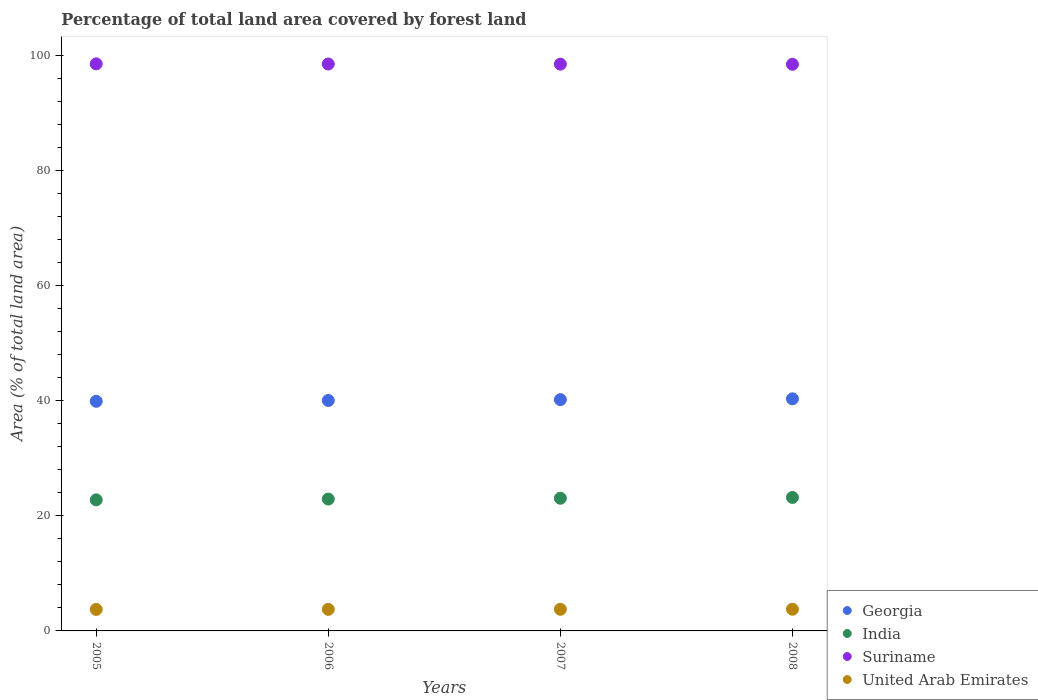How many different coloured dotlines are there?
Your answer should be very brief. 4. What is the percentage of forest land in Suriname in 2005?
Keep it short and to the point. 98.53. Across all years, what is the maximum percentage of forest land in Georgia?
Give a very brief answer. 40.33. Across all years, what is the minimum percentage of forest land in United Arab Emirates?
Your answer should be very brief. 3.73. In which year was the percentage of forest land in United Arab Emirates maximum?
Ensure brevity in your answer.  2008. In which year was the percentage of forest land in Suriname minimum?
Your response must be concise. 2008. What is the total percentage of forest land in Georgia in the graph?
Offer a very short reply. 160.45. What is the difference between the percentage of forest land in India in 2005 and that in 2006?
Offer a very short reply. -0.14. What is the difference between the percentage of forest land in United Arab Emirates in 2005 and the percentage of forest land in Suriname in 2007?
Offer a terse response. -94.75. What is the average percentage of forest land in Suriname per year?
Offer a terse response. 98.49. In the year 2008, what is the difference between the percentage of forest land in Georgia and percentage of forest land in Suriname?
Offer a terse response. -58.13. In how many years, is the percentage of forest land in Suriname greater than 64 %?
Keep it short and to the point. 4. What is the ratio of the percentage of forest land in India in 2005 to that in 2008?
Give a very brief answer. 0.98. What is the difference between the highest and the second highest percentage of forest land in Georgia?
Keep it short and to the point. 0.14. What is the difference between the highest and the lowest percentage of forest land in United Arab Emirates?
Your answer should be compact. 0.04. Is it the case that in every year, the sum of the percentage of forest land in Georgia and percentage of forest land in Suriname  is greater than the sum of percentage of forest land in United Arab Emirates and percentage of forest land in India?
Provide a short and direct response. No. Is it the case that in every year, the sum of the percentage of forest land in India and percentage of forest land in Suriname  is greater than the percentage of forest land in United Arab Emirates?
Make the answer very short. Yes. Does the percentage of forest land in Suriname monotonically increase over the years?
Offer a very short reply. No. Is the percentage of forest land in India strictly greater than the percentage of forest land in United Arab Emirates over the years?
Offer a very short reply. Yes. Is the percentage of forest land in Suriname strictly less than the percentage of forest land in India over the years?
Your response must be concise. No. What is the difference between two consecutive major ticks on the Y-axis?
Provide a short and direct response. 20. Does the graph contain grids?
Ensure brevity in your answer.  No. Where does the legend appear in the graph?
Ensure brevity in your answer.  Bottom right. How many legend labels are there?
Give a very brief answer. 4. How are the legend labels stacked?
Your answer should be compact. Vertical. What is the title of the graph?
Make the answer very short. Percentage of total land area covered by forest land. What is the label or title of the X-axis?
Provide a succinct answer. Years. What is the label or title of the Y-axis?
Your response must be concise. Area (% of total land area). What is the Area (% of total land area) of Georgia in 2005?
Your answer should be very brief. 39.9. What is the Area (% of total land area) in India in 2005?
Give a very brief answer. 22.77. What is the Area (% of total land area) of Suriname in 2005?
Your answer should be compact. 98.53. What is the Area (% of total land area) of United Arab Emirates in 2005?
Offer a terse response. 3.73. What is the Area (% of total land area) of Georgia in 2006?
Offer a terse response. 40.04. What is the Area (% of total land area) of India in 2006?
Make the answer very short. 22.91. What is the Area (% of total land area) of Suriname in 2006?
Offer a terse response. 98.51. What is the Area (% of total land area) of United Arab Emirates in 2006?
Your answer should be very brief. 3.74. What is the Area (% of total land area) in Georgia in 2007?
Your answer should be very brief. 40.19. What is the Area (% of total land area) in India in 2007?
Your response must be concise. 23.05. What is the Area (% of total land area) of Suriname in 2007?
Provide a succinct answer. 98.48. What is the Area (% of total land area) in United Arab Emirates in 2007?
Keep it short and to the point. 3.76. What is the Area (% of total land area) of Georgia in 2008?
Offer a very short reply. 40.33. What is the Area (% of total land area) of India in 2008?
Offer a terse response. 23.19. What is the Area (% of total land area) of Suriname in 2008?
Provide a short and direct response. 98.46. What is the Area (% of total land area) in United Arab Emirates in 2008?
Give a very brief answer. 3.77. Across all years, what is the maximum Area (% of total land area) of Georgia?
Offer a terse response. 40.33. Across all years, what is the maximum Area (% of total land area) in India?
Make the answer very short. 23.19. Across all years, what is the maximum Area (% of total land area) of Suriname?
Provide a succinct answer. 98.53. Across all years, what is the maximum Area (% of total land area) of United Arab Emirates?
Make the answer very short. 3.77. Across all years, what is the minimum Area (% of total land area) of Georgia?
Your response must be concise. 39.9. Across all years, what is the minimum Area (% of total land area) in India?
Make the answer very short. 22.77. Across all years, what is the minimum Area (% of total land area) of Suriname?
Your answer should be compact. 98.46. Across all years, what is the minimum Area (% of total land area) of United Arab Emirates?
Your answer should be very brief. 3.73. What is the total Area (% of total land area) of Georgia in the graph?
Offer a terse response. 160.45. What is the total Area (% of total land area) in India in the graph?
Provide a succinct answer. 91.93. What is the total Area (% of total land area) in Suriname in the graph?
Make the answer very short. 393.97. What is the total Area (% of total land area) in United Arab Emirates in the graph?
Provide a succinct answer. 15. What is the difference between the Area (% of total land area) in Georgia in 2005 and that in 2006?
Offer a very short reply. -0.14. What is the difference between the Area (% of total land area) in India in 2005 and that in 2006?
Your answer should be very brief. -0.14. What is the difference between the Area (% of total land area) in Suriname in 2005 and that in 2006?
Offer a terse response. 0.03. What is the difference between the Area (% of total land area) of United Arab Emirates in 2005 and that in 2006?
Offer a very short reply. -0.01. What is the difference between the Area (% of total land area) of Georgia in 2005 and that in 2007?
Offer a very short reply. -0.29. What is the difference between the Area (% of total land area) in India in 2005 and that in 2007?
Provide a short and direct response. -0.28. What is the difference between the Area (% of total land area) in Suriname in 2005 and that in 2007?
Ensure brevity in your answer.  0.05. What is the difference between the Area (% of total land area) in United Arab Emirates in 2005 and that in 2007?
Your answer should be compact. -0.03. What is the difference between the Area (% of total land area) of Georgia in 2005 and that in 2008?
Give a very brief answer. -0.43. What is the difference between the Area (% of total land area) of India in 2005 and that in 2008?
Your answer should be compact. -0.42. What is the difference between the Area (% of total land area) in Suriname in 2005 and that in 2008?
Provide a succinct answer. 0.08. What is the difference between the Area (% of total land area) in United Arab Emirates in 2005 and that in 2008?
Keep it short and to the point. -0.04. What is the difference between the Area (% of total land area) of Georgia in 2006 and that in 2007?
Your answer should be very brief. -0.14. What is the difference between the Area (% of total land area) in India in 2006 and that in 2007?
Provide a short and direct response. -0.14. What is the difference between the Area (% of total land area) of Suriname in 2006 and that in 2007?
Your answer should be very brief. 0.03. What is the difference between the Area (% of total land area) of United Arab Emirates in 2006 and that in 2007?
Keep it short and to the point. -0.01. What is the difference between the Area (% of total land area) in Georgia in 2006 and that in 2008?
Your response must be concise. -0.29. What is the difference between the Area (% of total land area) in India in 2006 and that in 2008?
Make the answer very short. -0.28. What is the difference between the Area (% of total land area) of Suriname in 2006 and that in 2008?
Provide a short and direct response. 0.05. What is the difference between the Area (% of total land area) in United Arab Emirates in 2006 and that in 2008?
Keep it short and to the point. -0.03. What is the difference between the Area (% of total land area) of Georgia in 2007 and that in 2008?
Keep it short and to the point. -0.14. What is the difference between the Area (% of total land area) of India in 2007 and that in 2008?
Provide a short and direct response. -0.14. What is the difference between the Area (% of total land area) of Suriname in 2007 and that in 2008?
Keep it short and to the point. 0.03. What is the difference between the Area (% of total land area) of United Arab Emirates in 2007 and that in 2008?
Offer a very short reply. -0.01. What is the difference between the Area (% of total land area) in Georgia in 2005 and the Area (% of total land area) in India in 2006?
Offer a very short reply. 16.98. What is the difference between the Area (% of total land area) of Georgia in 2005 and the Area (% of total land area) of Suriname in 2006?
Keep it short and to the point. -58.61. What is the difference between the Area (% of total land area) in Georgia in 2005 and the Area (% of total land area) in United Arab Emirates in 2006?
Give a very brief answer. 36.15. What is the difference between the Area (% of total land area) of India in 2005 and the Area (% of total land area) of Suriname in 2006?
Make the answer very short. -75.73. What is the difference between the Area (% of total land area) in India in 2005 and the Area (% of total land area) in United Arab Emirates in 2006?
Your answer should be very brief. 19.03. What is the difference between the Area (% of total land area) of Suriname in 2005 and the Area (% of total land area) of United Arab Emirates in 2006?
Keep it short and to the point. 94.79. What is the difference between the Area (% of total land area) in Georgia in 2005 and the Area (% of total land area) in India in 2007?
Offer a terse response. 16.84. What is the difference between the Area (% of total land area) in Georgia in 2005 and the Area (% of total land area) in Suriname in 2007?
Ensure brevity in your answer.  -58.58. What is the difference between the Area (% of total land area) of Georgia in 2005 and the Area (% of total land area) of United Arab Emirates in 2007?
Offer a very short reply. 36.14. What is the difference between the Area (% of total land area) in India in 2005 and the Area (% of total land area) in Suriname in 2007?
Make the answer very short. -75.71. What is the difference between the Area (% of total land area) of India in 2005 and the Area (% of total land area) of United Arab Emirates in 2007?
Your response must be concise. 19.02. What is the difference between the Area (% of total land area) in Suriname in 2005 and the Area (% of total land area) in United Arab Emirates in 2007?
Offer a terse response. 94.77. What is the difference between the Area (% of total land area) in Georgia in 2005 and the Area (% of total land area) in India in 2008?
Offer a terse response. 16.7. What is the difference between the Area (% of total land area) of Georgia in 2005 and the Area (% of total land area) of Suriname in 2008?
Your answer should be very brief. -58.56. What is the difference between the Area (% of total land area) in Georgia in 2005 and the Area (% of total land area) in United Arab Emirates in 2008?
Provide a succinct answer. 36.13. What is the difference between the Area (% of total land area) of India in 2005 and the Area (% of total land area) of Suriname in 2008?
Your answer should be compact. -75.68. What is the difference between the Area (% of total land area) of India in 2005 and the Area (% of total land area) of United Arab Emirates in 2008?
Keep it short and to the point. 19. What is the difference between the Area (% of total land area) in Suriname in 2005 and the Area (% of total land area) in United Arab Emirates in 2008?
Provide a succinct answer. 94.76. What is the difference between the Area (% of total land area) of Georgia in 2006 and the Area (% of total land area) of India in 2007?
Offer a terse response. 16.99. What is the difference between the Area (% of total land area) in Georgia in 2006 and the Area (% of total land area) in Suriname in 2007?
Keep it short and to the point. -58.44. What is the difference between the Area (% of total land area) of Georgia in 2006 and the Area (% of total land area) of United Arab Emirates in 2007?
Offer a terse response. 36.28. What is the difference between the Area (% of total land area) of India in 2006 and the Area (% of total land area) of Suriname in 2007?
Your response must be concise. -75.57. What is the difference between the Area (% of total land area) of India in 2006 and the Area (% of total land area) of United Arab Emirates in 2007?
Your response must be concise. 19.16. What is the difference between the Area (% of total land area) in Suriname in 2006 and the Area (% of total land area) in United Arab Emirates in 2007?
Ensure brevity in your answer.  94.75. What is the difference between the Area (% of total land area) in Georgia in 2006 and the Area (% of total land area) in India in 2008?
Make the answer very short. 16.85. What is the difference between the Area (% of total land area) in Georgia in 2006 and the Area (% of total land area) in Suriname in 2008?
Provide a short and direct response. -58.41. What is the difference between the Area (% of total land area) of Georgia in 2006 and the Area (% of total land area) of United Arab Emirates in 2008?
Your response must be concise. 36.27. What is the difference between the Area (% of total land area) of India in 2006 and the Area (% of total land area) of Suriname in 2008?
Your response must be concise. -75.54. What is the difference between the Area (% of total land area) of India in 2006 and the Area (% of total land area) of United Arab Emirates in 2008?
Ensure brevity in your answer.  19.14. What is the difference between the Area (% of total land area) in Suriname in 2006 and the Area (% of total land area) in United Arab Emirates in 2008?
Offer a very short reply. 94.74. What is the difference between the Area (% of total land area) of Georgia in 2007 and the Area (% of total land area) of India in 2008?
Your answer should be compact. 16.99. What is the difference between the Area (% of total land area) of Georgia in 2007 and the Area (% of total land area) of Suriname in 2008?
Your answer should be very brief. -58.27. What is the difference between the Area (% of total land area) of Georgia in 2007 and the Area (% of total land area) of United Arab Emirates in 2008?
Offer a very short reply. 36.41. What is the difference between the Area (% of total land area) of India in 2007 and the Area (% of total land area) of Suriname in 2008?
Offer a terse response. -75.4. What is the difference between the Area (% of total land area) of India in 2007 and the Area (% of total land area) of United Arab Emirates in 2008?
Keep it short and to the point. 19.28. What is the difference between the Area (% of total land area) of Suriname in 2007 and the Area (% of total land area) of United Arab Emirates in 2008?
Offer a terse response. 94.71. What is the average Area (% of total land area) in Georgia per year?
Give a very brief answer. 40.11. What is the average Area (% of total land area) of India per year?
Ensure brevity in your answer.  22.98. What is the average Area (% of total land area) in Suriname per year?
Your answer should be very brief. 98.49. What is the average Area (% of total land area) in United Arab Emirates per year?
Offer a very short reply. 3.75. In the year 2005, what is the difference between the Area (% of total land area) in Georgia and Area (% of total land area) in India?
Provide a succinct answer. 17.12. In the year 2005, what is the difference between the Area (% of total land area) of Georgia and Area (% of total land area) of Suriname?
Keep it short and to the point. -58.63. In the year 2005, what is the difference between the Area (% of total land area) in Georgia and Area (% of total land area) in United Arab Emirates?
Your answer should be compact. 36.17. In the year 2005, what is the difference between the Area (% of total land area) of India and Area (% of total land area) of Suriname?
Your answer should be very brief. -75.76. In the year 2005, what is the difference between the Area (% of total land area) in India and Area (% of total land area) in United Arab Emirates?
Give a very brief answer. 19.04. In the year 2005, what is the difference between the Area (% of total land area) of Suriname and Area (% of total land area) of United Arab Emirates?
Your response must be concise. 94.8. In the year 2006, what is the difference between the Area (% of total land area) of Georgia and Area (% of total land area) of India?
Your answer should be very brief. 17.13. In the year 2006, what is the difference between the Area (% of total land area) in Georgia and Area (% of total land area) in Suriname?
Make the answer very short. -58.47. In the year 2006, what is the difference between the Area (% of total land area) of Georgia and Area (% of total land area) of United Arab Emirates?
Provide a short and direct response. 36.3. In the year 2006, what is the difference between the Area (% of total land area) in India and Area (% of total land area) in Suriname?
Your answer should be compact. -75.59. In the year 2006, what is the difference between the Area (% of total land area) in India and Area (% of total land area) in United Arab Emirates?
Your answer should be compact. 19.17. In the year 2006, what is the difference between the Area (% of total land area) in Suriname and Area (% of total land area) in United Arab Emirates?
Give a very brief answer. 94.76. In the year 2007, what is the difference between the Area (% of total land area) of Georgia and Area (% of total land area) of India?
Your answer should be very brief. 17.13. In the year 2007, what is the difference between the Area (% of total land area) in Georgia and Area (% of total land area) in Suriname?
Your answer should be compact. -58.3. In the year 2007, what is the difference between the Area (% of total land area) in Georgia and Area (% of total land area) in United Arab Emirates?
Ensure brevity in your answer.  36.43. In the year 2007, what is the difference between the Area (% of total land area) of India and Area (% of total land area) of Suriname?
Your answer should be compact. -75.43. In the year 2007, what is the difference between the Area (% of total land area) in India and Area (% of total land area) in United Arab Emirates?
Offer a very short reply. 19.3. In the year 2007, what is the difference between the Area (% of total land area) in Suriname and Area (% of total land area) in United Arab Emirates?
Give a very brief answer. 94.72. In the year 2008, what is the difference between the Area (% of total land area) in Georgia and Area (% of total land area) in India?
Ensure brevity in your answer.  17.14. In the year 2008, what is the difference between the Area (% of total land area) of Georgia and Area (% of total land area) of Suriname?
Keep it short and to the point. -58.13. In the year 2008, what is the difference between the Area (% of total land area) in Georgia and Area (% of total land area) in United Arab Emirates?
Your answer should be compact. 36.56. In the year 2008, what is the difference between the Area (% of total land area) of India and Area (% of total land area) of Suriname?
Your response must be concise. -75.26. In the year 2008, what is the difference between the Area (% of total land area) in India and Area (% of total land area) in United Arab Emirates?
Provide a short and direct response. 19.42. In the year 2008, what is the difference between the Area (% of total land area) of Suriname and Area (% of total land area) of United Arab Emirates?
Your answer should be compact. 94.69. What is the ratio of the Area (% of total land area) in Georgia in 2005 to that in 2006?
Offer a terse response. 1. What is the ratio of the Area (% of total land area) in India in 2005 to that in 2006?
Offer a very short reply. 0.99. What is the ratio of the Area (% of total land area) of United Arab Emirates in 2005 to that in 2006?
Keep it short and to the point. 1. What is the ratio of the Area (% of total land area) of Georgia in 2005 to that in 2007?
Provide a succinct answer. 0.99. What is the ratio of the Area (% of total land area) in India in 2005 to that in 2007?
Your answer should be compact. 0.99. What is the ratio of the Area (% of total land area) in United Arab Emirates in 2005 to that in 2007?
Make the answer very short. 0.99. What is the ratio of the Area (% of total land area) in Georgia in 2005 to that in 2008?
Ensure brevity in your answer.  0.99. What is the ratio of the Area (% of total land area) in India in 2005 to that in 2008?
Give a very brief answer. 0.98. What is the ratio of the Area (% of total land area) in Suriname in 2005 to that in 2008?
Your answer should be very brief. 1. What is the ratio of the Area (% of total land area) of United Arab Emirates in 2005 to that in 2008?
Your response must be concise. 0.99. What is the ratio of the Area (% of total land area) of India in 2006 to that in 2008?
Make the answer very short. 0.99. What is the ratio of the Area (% of total land area) in United Arab Emirates in 2006 to that in 2008?
Keep it short and to the point. 0.99. What is the ratio of the Area (% of total land area) of Suriname in 2007 to that in 2008?
Your answer should be compact. 1. What is the ratio of the Area (% of total land area) of United Arab Emirates in 2007 to that in 2008?
Provide a succinct answer. 1. What is the difference between the highest and the second highest Area (% of total land area) in Georgia?
Provide a short and direct response. 0.14. What is the difference between the highest and the second highest Area (% of total land area) in India?
Make the answer very short. 0.14. What is the difference between the highest and the second highest Area (% of total land area) in Suriname?
Ensure brevity in your answer.  0.03. What is the difference between the highest and the second highest Area (% of total land area) of United Arab Emirates?
Offer a terse response. 0.01. What is the difference between the highest and the lowest Area (% of total land area) of Georgia?
Your response must be concise. 0.43. What is the difference between the highest and the lowest Area (% of total land area) of India?
Offer a very short reply. 0.42. What is the difference between the highest and the lowest Area (% of total land area) of Suriname?
Keep it short and to the point. 0.08. What is the difference between the highest and the lowest Area (% of total land area) of United Arab Emirates?
Provide a short and direct response. 0.04. 